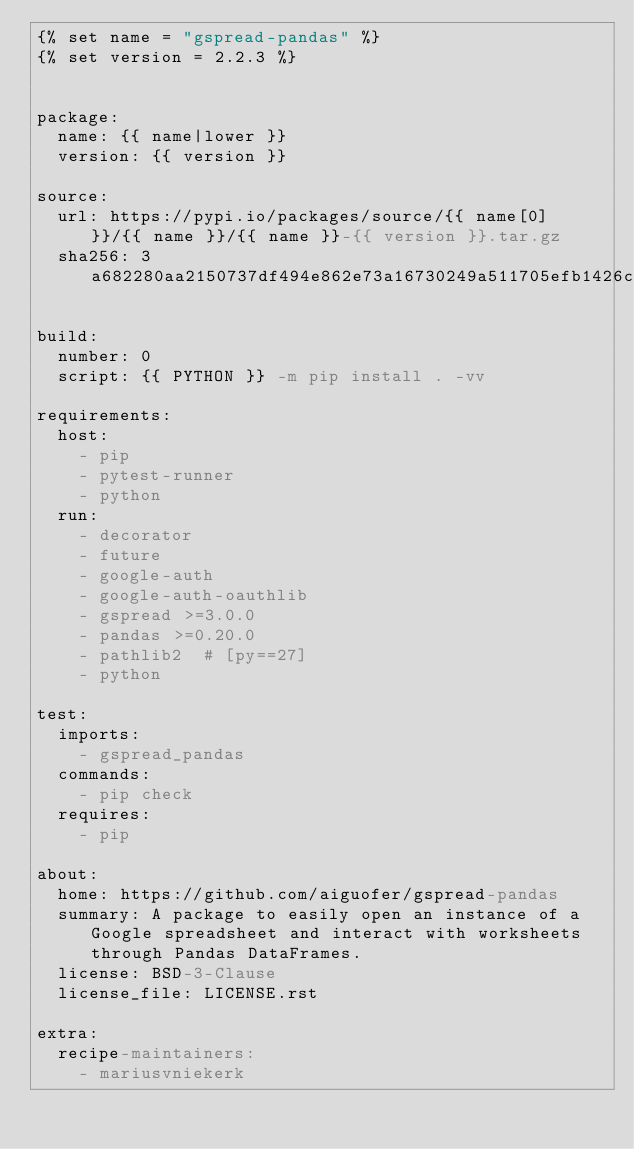<code> <loc_0><loc_0><loc_500><loc_500><_YAML_>{% set name = "gspread-pandas" %}
{% set version = 2.2.3 %}


package:
  name: {{ name|lower }}
  version: {{ version }}

source:
  url: https://pypi.io/packages/source/{{ name[0] }}/{{ name }}/{{ name }}-{{ version }}.tar.gz
  sha256: 3a682280aa2150737df494e862e73a16730249a511705efb1426cd379f23f397

build:
  number: 0
  script: {{ PYTHON }} -m pip install . -vv

requirements:
  host:
    - pip
    - pytest-runner
    - python
  run:
    - decorator
    - future
    - google-auth
    - google-auth-oauthlib
    - gspread >=3.0.0
    - pandas >=0.20.0
    - pathlib2  # [py==27]
    - python

test:
  imports:
    - gspread_pandas
  commands:
    - pip check
  requires:
    - pip

about:
  home: https://github.com/aiguofer/gspread-pandas
  summary: A package to easily open an instance of a Google spreadsheet and interact with worksheets through Pandas DataFrames.
  license: BSD-3-Clause
  license_file: LICENSE.rst

extra:
  recipe-maintainers:
    - mariusvniekerk
</code> 